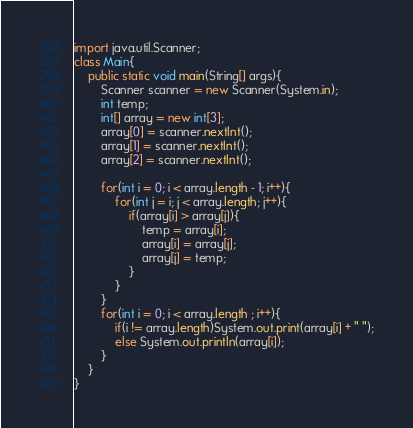<code> <loc_0><loc_0><loc_500><loc_500><_Java_>import java.util.Scanner;
class Main{
    public static void main(String[] args){
        Scanner scanner = new Scanner(System.in);
        int temp;
        int[] array = new int[3];
        array[0] = scanner.nextInt();
        array[1] = scanner.nextInt();
        array[2] = scanner.nextInt();

        for(int i = 0; i < array.length - 1; i++){
            for(int j = i; j < array.length; j++){
                if(array[i] > array[j]){
                    temp = array[i];
                    array[i] = array[j];
                    array[j] = temp;
                }
            }
        }
        for(int i = 0; i < array.length ; i++){
            if(i != array.length)System.out.print(array[i] + " ");
            else System.out.println(array[i]);
        }
    }
}

</code> 